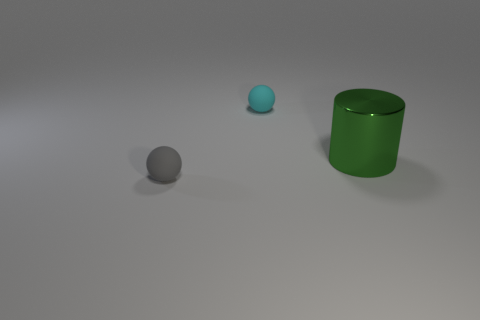What is the color of the matte object left of the cyan thing that is right of the tiny rubber sphere to the left of the tiny cyan matte thing?
Ensure brevity in your answer.  Gray. Are there any tiny cyan rubber things of the same shape as the shiny object?
Your answer should be very brief. No. There is a object that is the same size as the gray rubber sphere; what color is it?
Ensure brevity in your answer.  Cyan. There is a tiny ball that is on the right side of the gray sphere; what is it made of?
Offer a terse response. Rubber. There is a thing on the right side of the small cyan matte object; does it have the same shape as the tiny object in front of the small cyan rubber thing?
Offer a terse response. No. Is the number of big metal things right of the green thing the same as the number of objects?
Give a very brief answer. No. What number of green cylinders are the same material as the small cyan ball?
Keep it short and to the point. 0. There is another thing that is the same material as the gray thing; what is its color?
Give a very brief answer. Cyan. There is a green metallic object; is it the same size as the matte sphere that is behind the big metallic thing?
Provide a short and direct response. No. What is the shape of the small cyan thing?
Offer a terse response. Sphere. 